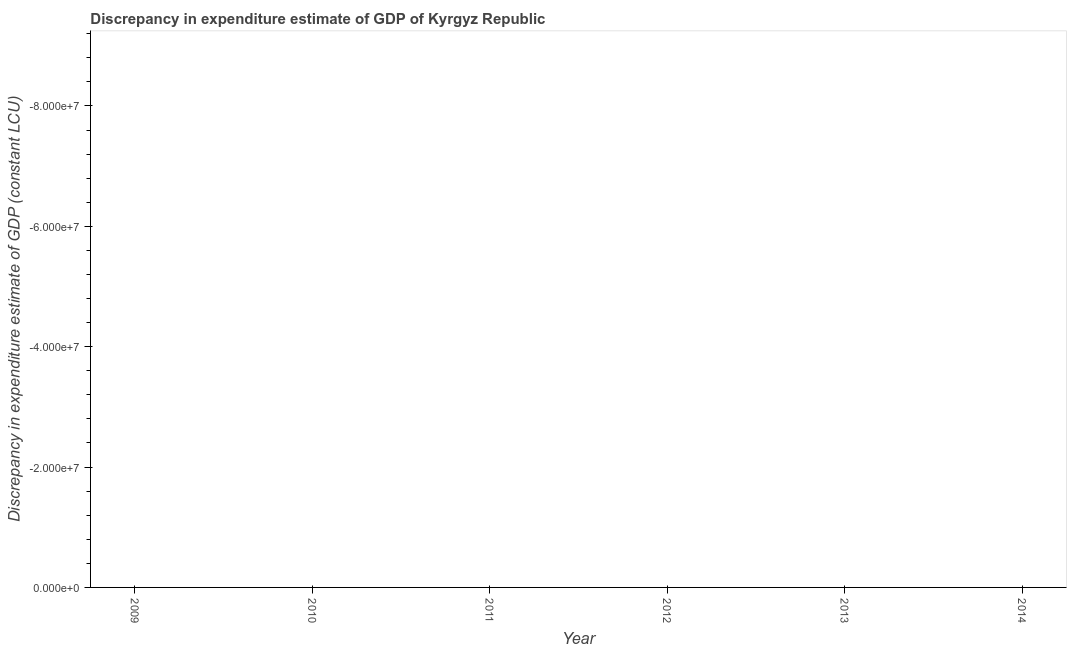Across all years, what is the minimum discrepancy in expenditure estimate of gdp?
Ensure brevity in your answer.  0. What is the average discrepancy in expenditure estimate of gdp per year?
Keep it short and to the point. 0. Does the discrepancy in expenditure estimate of gdp monotonically increase over the years?
Keep it short and to the point. No. How many years are there in the graph?
Keep it short and to the point. 6. What is the difference between two consecutive major ticks on the Y-axis?
Provide a short and direct response. 2.00e+07. Does the graph contain grids?
Provide a short and direct response. No. What is the title of the graph?
Keep it short and to the point. Discrepancy in expenditure estimate of GDP of Kyrgyz Republic. What is the label or title of the X-axis?
Your answer should be compact. Year. What is the label or title of the Y-axis?
Offer a very short reply. Discrepancy in expenditure estimate of GDP (constant LCU). What is the Discrepancy in expenditure estimate of GDP (constant LCU) in 2010?
Offer a terse response. 0. 